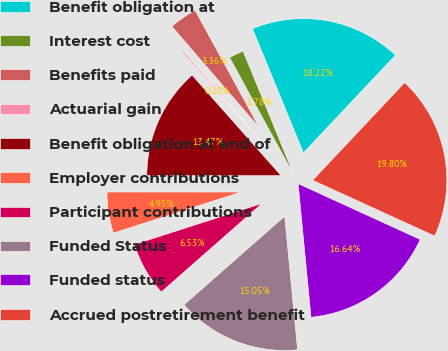Convert chart to OTSL. <chart><loc_0><loc_0><loc_500><loc_500><pie_chart><fcel>Benefit obligation at<fcel>Interest cost<fcel>Benefits paid<fcel>Actuarial gain<fcel>Benefit obligation at end of<fcel>Employer contributions<fcel>Participant contributions<fcel>Funded Status<fcel>Funded status<fcel>Accrued postretirement benefit<nl><fcel>18.22%<fcel>1.78%<fcel>3.36%<fcel>0.2%<fcel>13.47%<fcel>4.95%<fcel>6.53%<fcel>15.05%<fcel>16.64%<fcel>19.8%<nl></chart> 